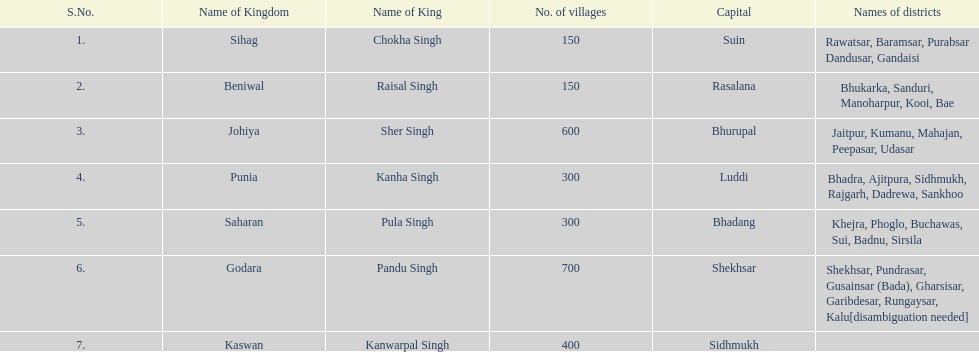After sihag, what kingdom is listed next? Beniwal. 